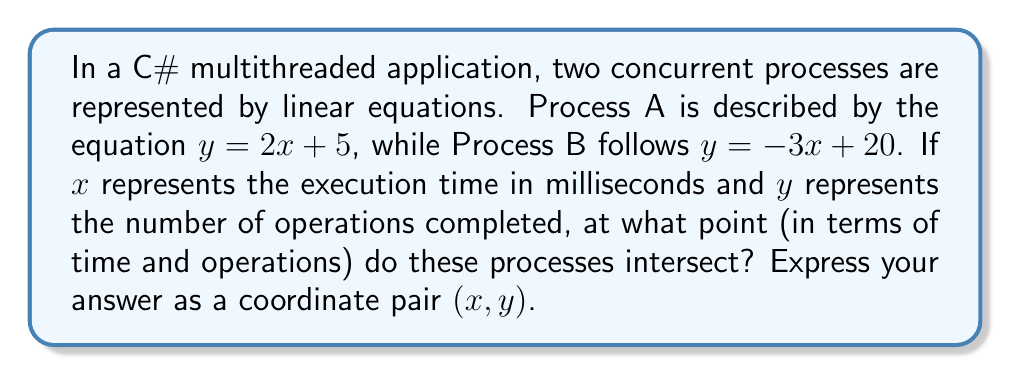Provide a solution to this math problem. To find the intersection point of two lines, we need to solve the system of equations:

$$
\begin{cases}
y = 2x + 5 \\
y = -3x + 20
\end{cases}
$$

Step 1: Set the equations equal to each other
$2x + 5 = -3x + 20$

Step 2: Solve for x
$2x + 3x = 20 - 5$
$5x = 15$
$x = 3$

Step 3: Substitute x = 3 into either equation to find y
Using $y = 2x + 5$:
$y = 2(3) + 5 = 6 + 5 = 11$

Step 4: Express the solution as a coordinate pair
The intersection point is $(3, 11)$

In the context of the multithreaded application:
- The processes intersect after 3 milliseconds of execution time
- At this point, both processes have completed 11 operations
Answer: $(3, 11)$ 